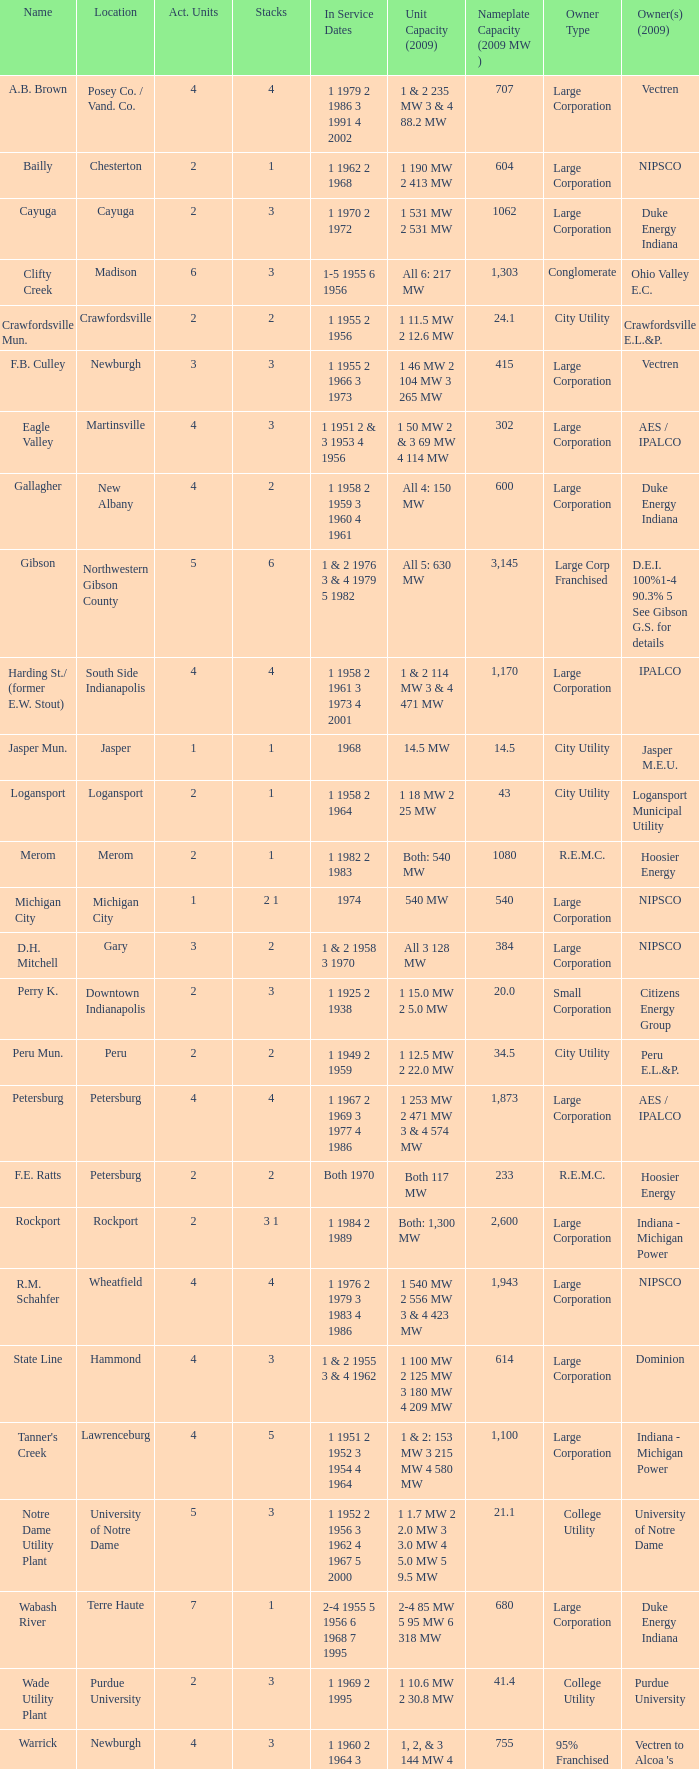Name the owners 2009 for south side indianapolis IPALCO. 